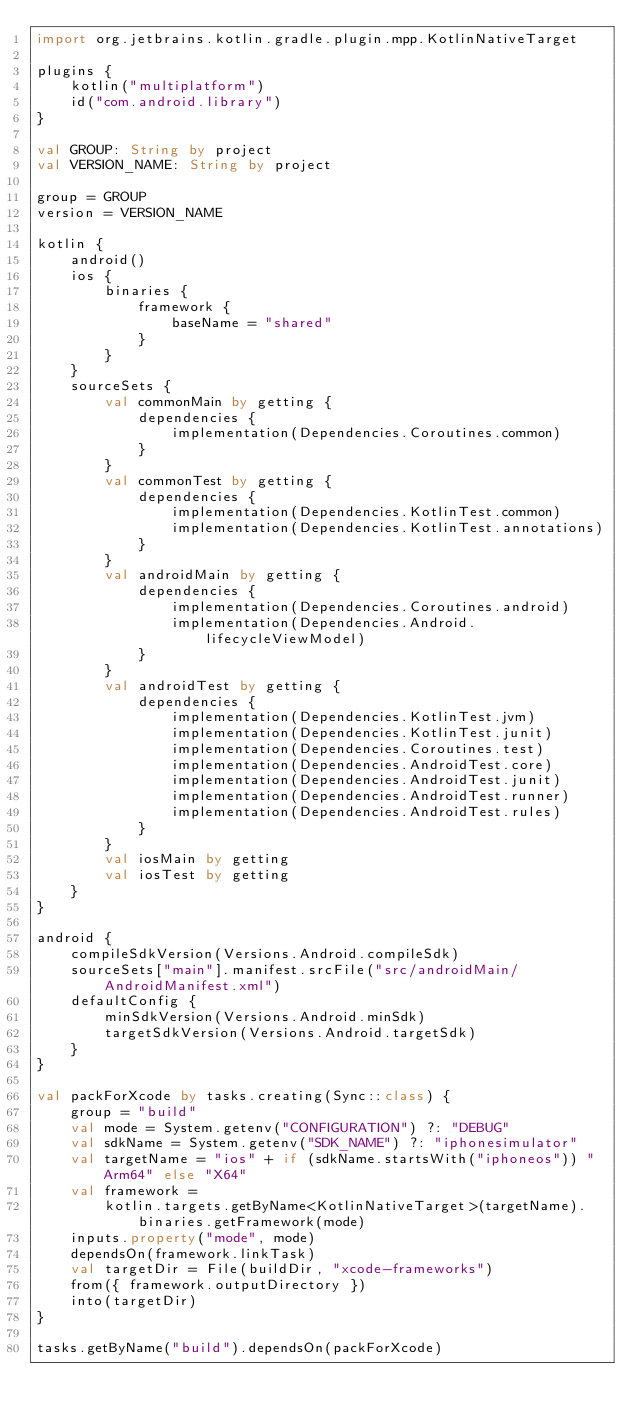Convert code to text. <code><loc_0><loc_0><loc_500><loc_500><_Kotlin_>import org.jetbrains.kotlin.gradle.plugin.mpp.KotlinNativeTarget

plugins {
    kotlin("multiplatform")
    id("com.android.library")
}

val GROUP: String by project
val VERSION_NAME: String by project

group = GROUP
version = VERSION_NAME

kotlin {
    android()
    ios {
        binaries {
            framework {
                baseName = "shared"
            }
        }
    }
    sourceSets {
        val commonMain by getting {
            dependencies {
                implementation(Dependencies.Coroutines.common)
            }
        }
        val commonTest by getting {
            dependencies {
                implementation(Dependencies.KotlinTest.common)
                implementation(Dependencies.KotlinTest.annotations)
            }
        }
        val androidMain by getting {
            dependencies {
                implementation(Dependencies.Coroutines.android)
                implementation(Dependencies.Android.lifecycleViewModel)
            }
        }
        val androidTest by getting {
            dependencies {
                implementation(Dependencies.KotlinTest.jvm)
                implementation(Dependencies.KotlinTest.junit)
                implementation(Dependencies.Coroutines.test)
                implementation(Dependencies.AndroidTest.core)
                implementation(Dependencies.AndroidTest.junit)
                implementation(Dependencies.AndroidTest.runner)
                implementation(Dependencies.AndroidTest.rules)
            }
        }
        val iosMain by getting
        val iosTest by getting
    }
}

android {
    compileSdkVersion(Versions.Android.compileSdk)
    sourceSets["main"].manifest.srcFile("src/androidMain/AndroidManifest.xml")
    defaultConfig {
        minSdkVersion(Versions.Android.minSdk)
        targetSdkVersion(Versions.Android.targetSdk)
    }
}

val packForXcode by tasks.creating(Sync::class) {
    group = "build"
    val mode = System.getenv("CONFIGURATION") ?: "DEBUG"
    val sdkName = System.getenv("SDK_NAME") ?: "iphonesimulator"
    val targetName = "ios" + if (sdkName.startsWith("iphoneos")) "Arm64" else "X64"
    val framework =
        kotlin.targets.getByName<KotlinNativeTarget>(targetName).binaries.getFramework(mode)
    inputs.property("mode", mode)
    dependsOn(framework.linkTask)
    val targetDir = File(buildDir, "xcode-frameworks")
    from({ framework.outputDirectory })
    into(targetDir)
}

tasks.getByName("build").dependsOn(packForXcode)</code> 